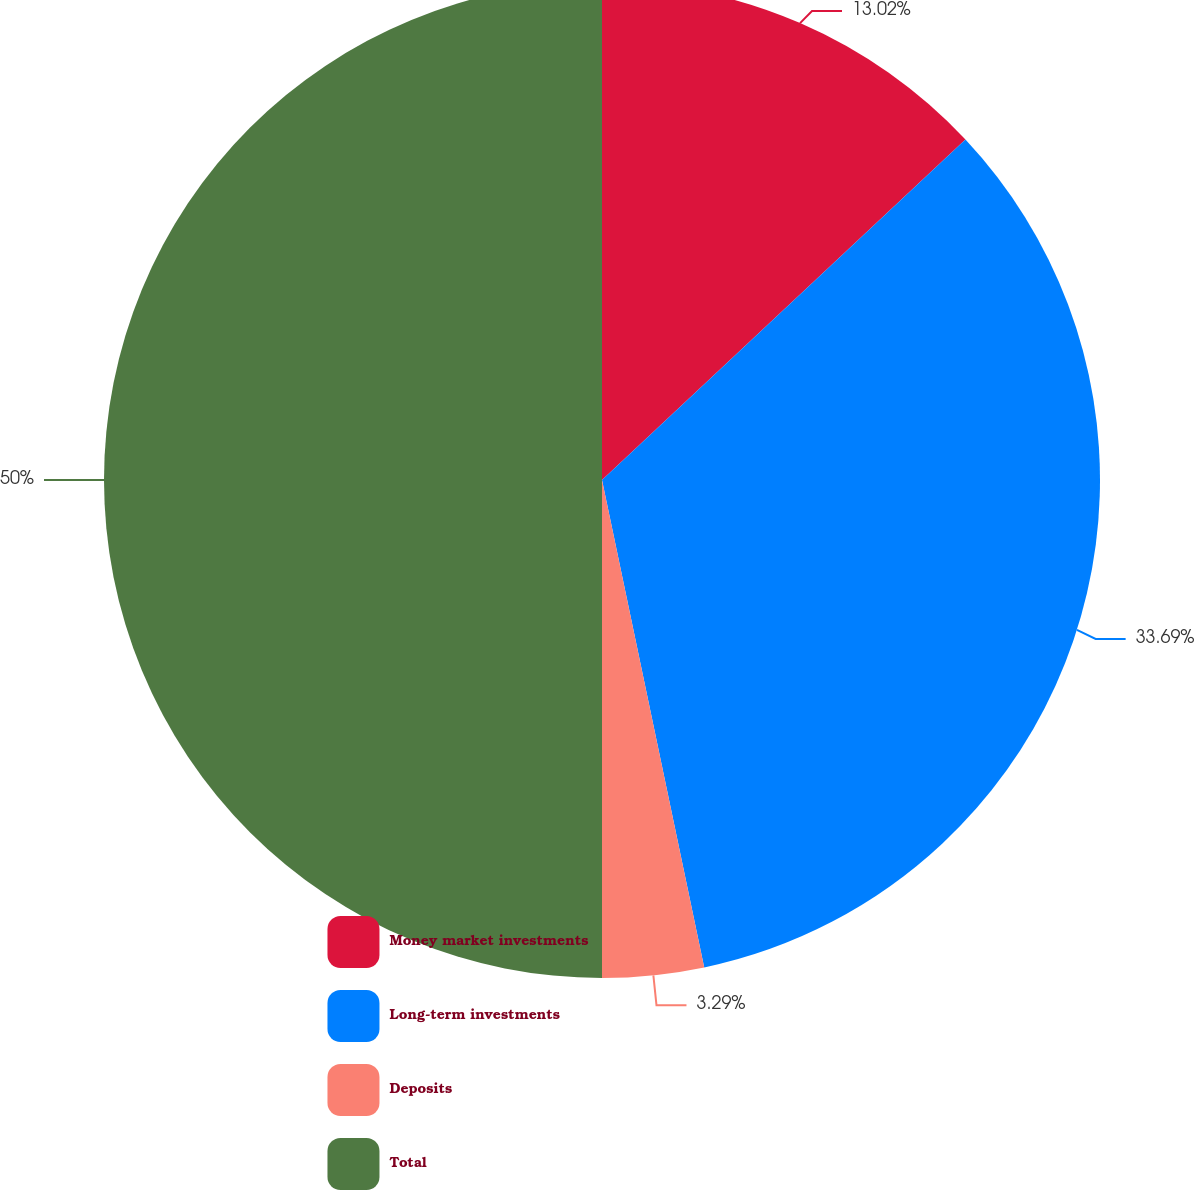<chart> <loc_0><loc_0><loc_500><loc_500><pie_chart><fcel>Money market investments<fcel>Long-term investments<fcel>Deposits<fcel>Total<nl><fcel>13.02%<fcel>33.69%<fcel>3.29%<fcel>50.0%<nl></chart> 